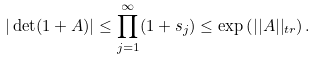<formula> <loc_0><loc_0><loc_500><loc_500>| \det ( 1 + A ) | \leq \prod _ { j = 1 } ^ { \infty } ( 1 + s _ { j } ) \leq \exp \left ( | | A | | _ { t r } \right ) .</formula> 